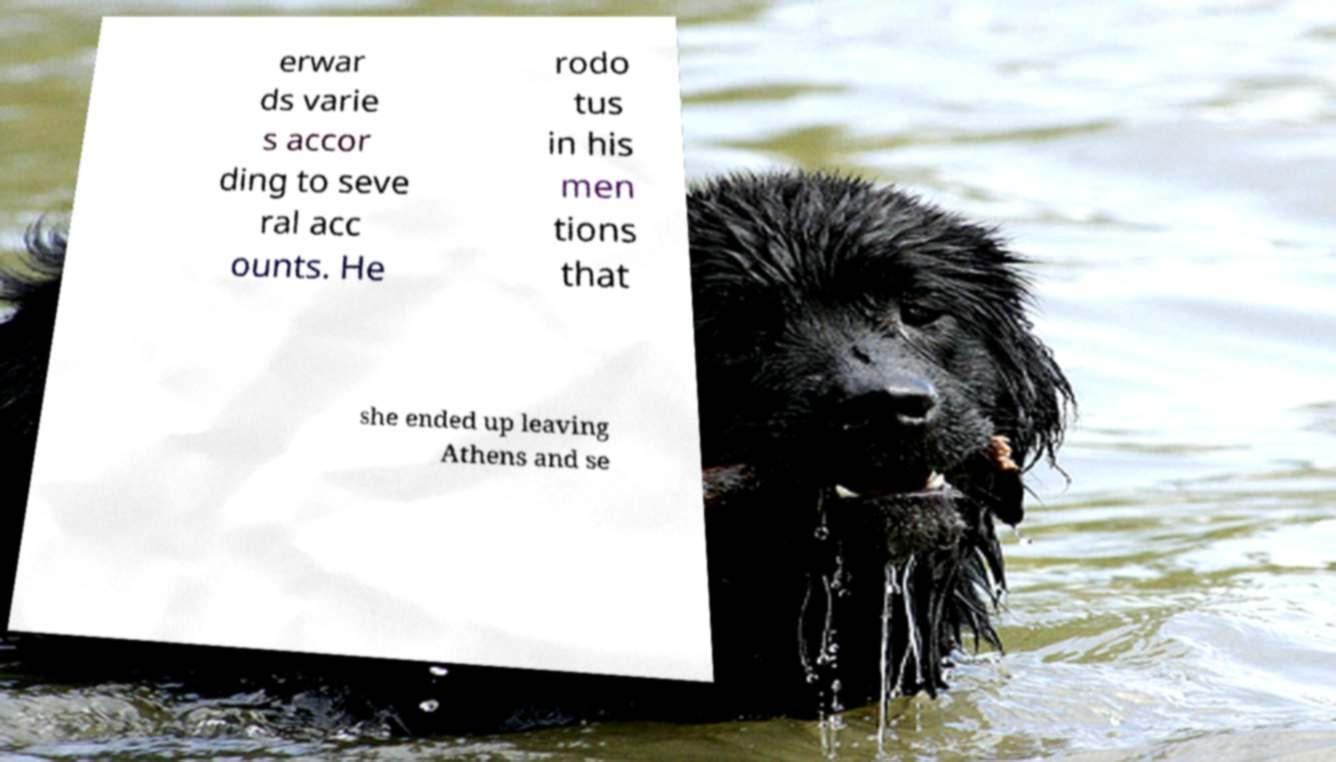I need the written content from this picture converted into text. Can you do that? erwar ds varie s accor ding to seve ral acc ounts. He rodo tus in his men tions that she ended up leaving Athens and se 